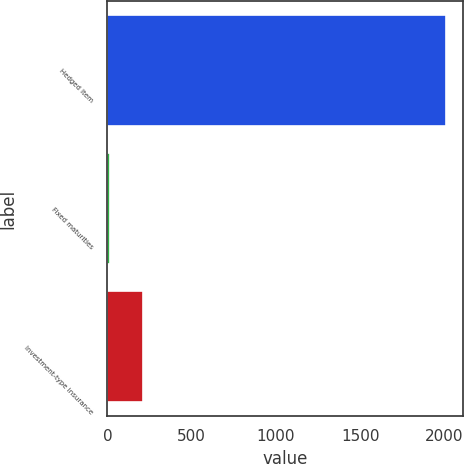Convert chart to OTSL. <chart><loc_0><loc_0><loc_500><loc_500><bar_chart><fcel>Hedged Item<fcel>Fixed maturities<fcel>Investment-type insurance<nl><fcel>2007<fcel>13.1<fcel>212.49<nl></chart> 